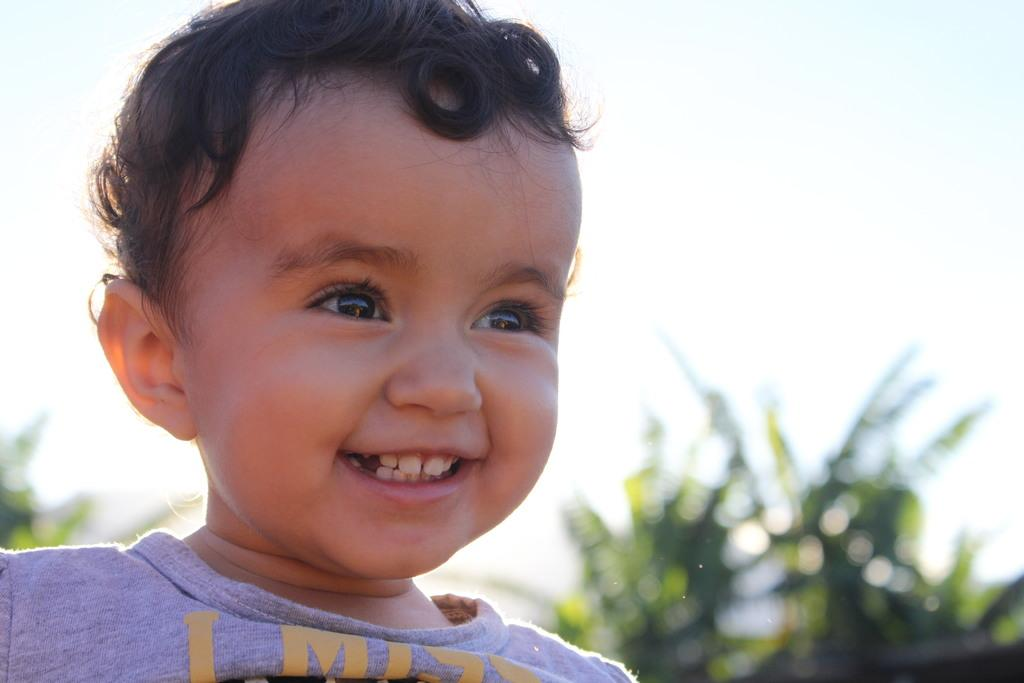What is the main subject of the image? There is a child in the image. What can be seen in the background of the image? There are trees in the background of the image. What is visible at the top of the image? The sky is visible at the top of the image. What color is the cherry that the child is holding in the image? There is no cherry present in the image, so it cannot be determined what color it might be. 